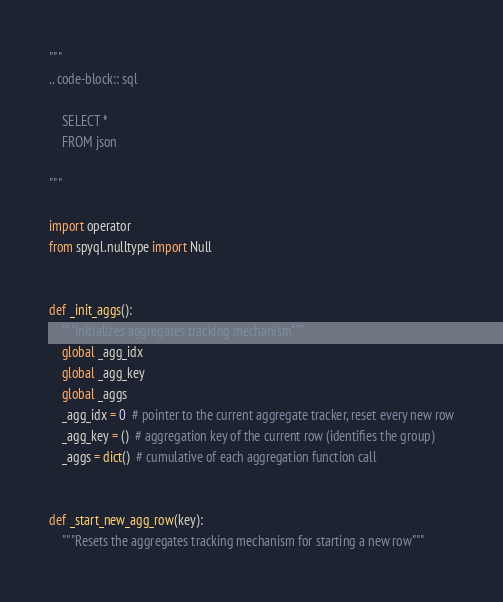<code> <loc_0><loc_0><loc_500><loc_500><_Python_>"""
.. code-block:: sql

    SELECT *
    FROM json

"""

import operator
from spyql.nulltype import Null


def _init_aggs():
    """Initializes aggregates tracking mechanism"""
    global _agg_idx
    global _agg_key
    global _aggs
    _agg_idx = 0  # pointer to the current aggregate tracker, reset every new row
    _agg_key = ()  # aggregation key of the current row (identifies the group)
    _aggs = dict()  # cumulative of each aggregation function call


def _start_new_agg_row(key):
    """Resets the aggregates tracking mechanism for starting a new row"""</code> 